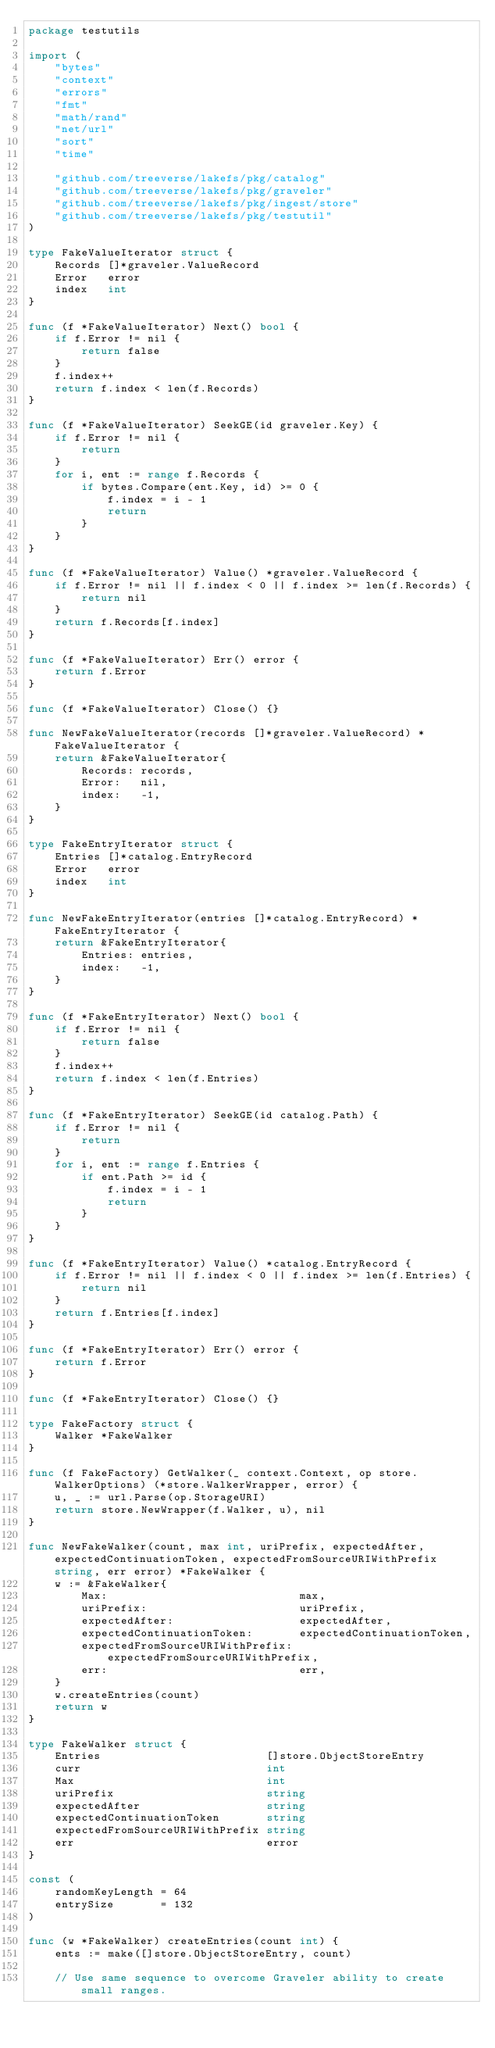Convert code to text. <code><loc_0><loc_0><loc_500><loc_500><_Go_>package testutils

import (
	"bytes"
	"context"
	"errors"
	"fmt"
	"math/rand"
	"net/url"
	"sort"
	"time"

	"github.com/treeverse/lakefs/pkg/catalog"
	"github.com/treeverse/lakefs/pkg/graveler"
	"github.com/treeverse/lakefs/pkg/ingest/store"
	"github.com/treeverse/lakefs/pkg/testutil"
)

type FakeValueIterator struct {
	Records []*graveler.ValueRecord
	Error   error
	index   int
}

func (f *FakeValueIterator) Next() bool {
	if f.Error != nil {
		return false
	}
	f.index++
	return f.index < len(f.Records)
}

func (f *FakeValueIterator) SeekGE(id graveler.Key) {
	if f.Error != nil {
		return
	}
	for i, ent := range f.Records {
		if bytes.Compare(ent.Key, id) >= 0 {
			f.index = i - 1
			return
		}
	}
}

func (f *FakeValueIterator) Value() *graveler.ValueRecord {
	if f.Error != nil || f.index < 0 || f.index >= len(f.Records) {
		return nil
	}
	return f.Records[f.index]
}

func (f *FakeValueIterator) Err() error {
	return f.Error
}

func (f *FakeValueIterator) Close() {}

func NewFakeValueIterator(records []*graveler.ValueRecord) *FakeValueIterator {
	return &FakeValueIterator{
		Records: records,
		Error:   nil,
		index:   -1,
	}
}

type FakeEntryIterator struct {
	Entries []*catalog.EntryRecord
	Error   error
	index   int
}

func NewFakeEntryIterator(entries []*catalog.EntryRecord) *FakeEntryIterator {
	return &FakeEntryIterator{
		Entries: entries,
		index:   -1,
	}
}

func (f *FakeEntryIterator) Next() bool {
	if f.Error != nil {
		return false
	}
	f.index++
	return f.index < len(f.Entries)
}

func (f *FakeEntryIterator) SeekGE(id catalog.Path) {
	if f.Error != nil {
		return
	}
	for i, ent := range f.Entries {
		if ent.Path >= id {
			f.index = i - 1
			return
		}
	}
}

func (f *FakeEntryIterator) Value() *catalog.EntryRecord {
	if f.Error != nil || f.index < 0 || f.index >= len(f.Entries) {
		return nil
	}
	return f.Entries[f.index]
}

func (f *FakeEntryIterator) Err() error {
	return f.Error
}

func (f *FakeEntryIterator) Close() {}

type FakeFactory struct {
	Walker *FakeWalker
}

func (f FakeFactory) GetWalker(_ context.Context, op store.WalkerOptions) (*store.WalkerWrapper, error) {
	u, _ := url.Parse(op.StorageURI)
	return store.NewWrapper(f.Walker, u), nil
}

func NewFakeWalker(count, max int, uriPrefix, expectedAfter, expectedContinuationToken, expectedFromSourceURIWithPrefix string, err error) *FakeWalker {
	w := &FakeWalker{
		Max:                             max,
		uriPrefix:                       uriPrefix,
		expectedAfter:                   expectedAfter,
		expectedContinuationToken:       expectedContinuationToken,
		expectedFromSourceURIWithPrefix: expectedFromSourceURIWithPrefix,
		err:                             err,
	}
	w.createEntries(count)
	return w
}

type FakeWalker struct {
	Entries                         []store.ObjectStoreEntry
	curr                            int
	Max                             int
	uriPrefix                       string
	expectedAfter                   string
	expectedContinuationToken       string
	expectedFromSourceURIWithPrefix string
	err                             error
}

const (
	randomKeyLength = 64
	entrySize       = 132
)

func (w *FakeWalker) createEntries(count int) {
	ents := make([]store.ObjectStoreEntry, count)

	// Use same sequence to overcome Graveler ability to create small ranges.</code> 